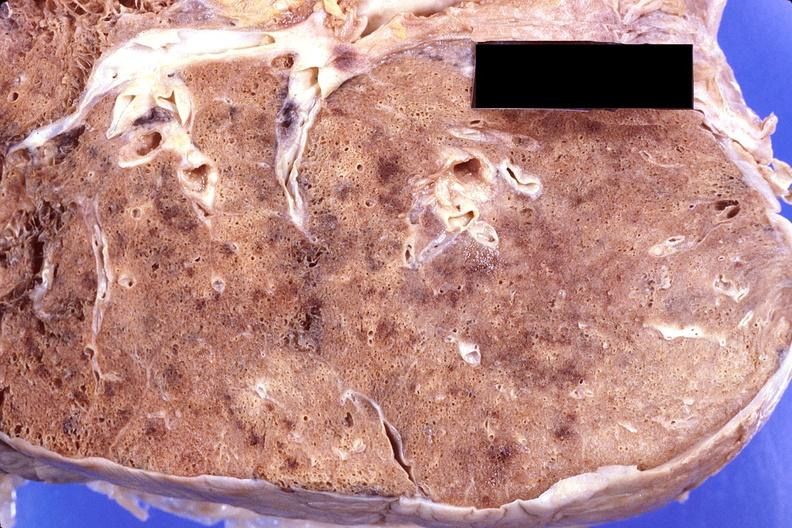does this image show lung, cryptococcal pneumonia?
Answer the question using a single word or phrase. Yes 